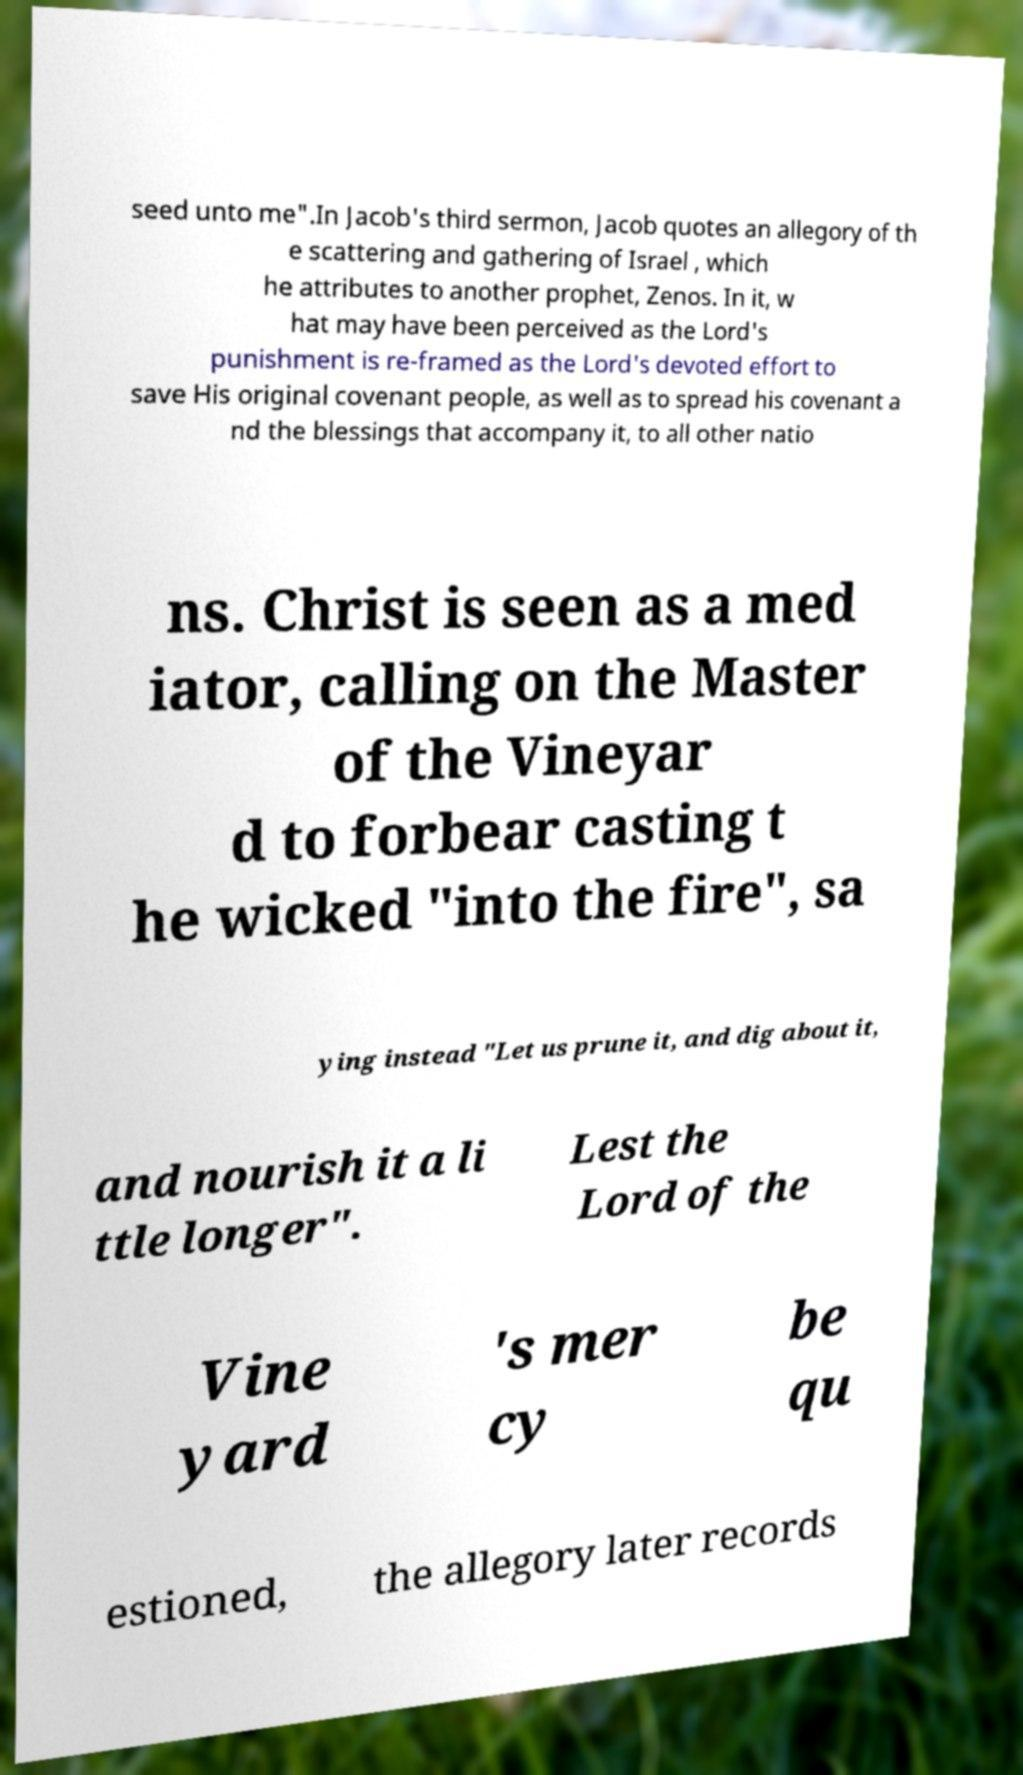What messages or text are displayed in this image? I need them in a readable, typed format. seed unto me".In Jacob's third sermon, Jacob quotes an allegory of th e scattering and gathering of Israel , which he attributes to another prophet, Zenos. In it, w hat may have been perceived as the Lord's punishment is re-framed as the Lord's devoted effort to save His original covenant people, as well as to spread his covenant a nd the blessings that accompany it, to all other natio ns. Christ is seen as a med iator, calling on the Master of the Vineyar d to forbear casting t he wicked "into the fire", sa ying instead "Let us prune it, and dig about it, and nourish it a li ttle longer". Lest the Lord of the Vine yard 's mer cy be qu estioned, the allegory later records 